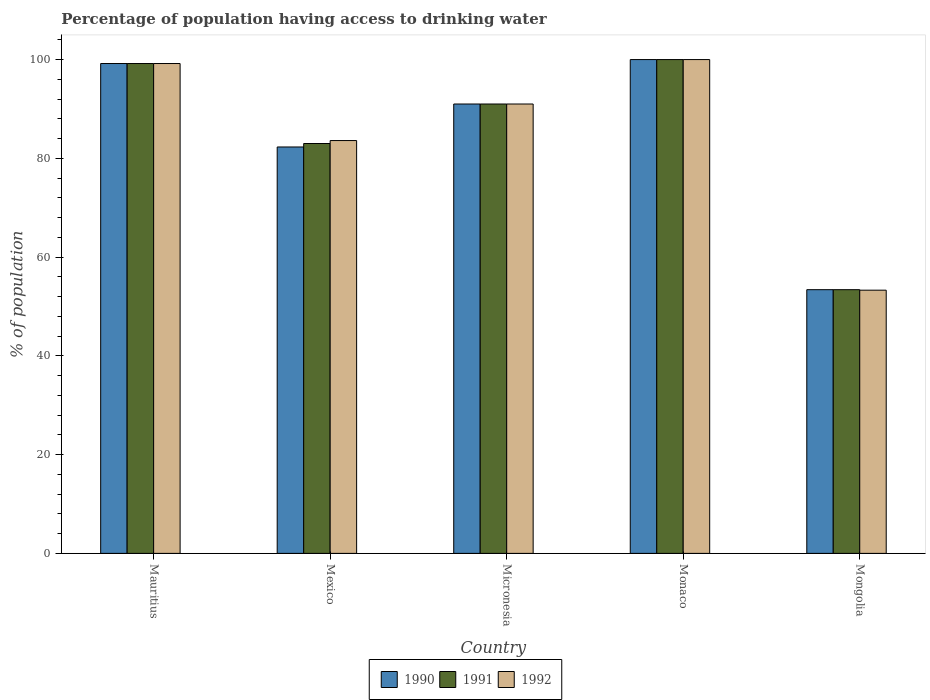How many different coloured bars are there?
Your answer should be very brief. 3. How many groups of bars are there?
Keep it short and to the point. 5. How many bars are there on the 1st tick from the right?
Ensure brevity in your answer.  3. What is the label of the 5th group of bars from the left?
Offer a very short reply. Mongolia. In how many cases, is the number of bars for a given country not equal to the number of legend labels?
Make the answer very short. 0. What is the percentage of population having access to drinking water in 1992 in Mexico?
Ensure brevity in your answer.  83.6. Across all countries, what is the minimum percentage of population having access to drinking water in 1990?
Ensure brevity in your answer.  53.4. In which country was the percentage of population having access to drinking water in 1992 maximum?
Provide a short and direct response. Monaco. In which country was the percentage of population having access to drinking water in 1991 minimum?
Ensure brevity in your answer.  Mongolia. What is the total percentage of population having access to drinking water in 1990 in the graph?
Offer a very short reply. 425.9. What is the difference between the percentage of population having access to drinking water in 1991 in Mauritius and the percentage of population having access to drinking water in 1992 in Monaco?
Your answer should be very brief. -0.8. What is the average percentage of population having access to drinking water in 1992 per country?
Your answer should be compact. 85.42. What is the ratio of the percentage of population having access to drinking water in 1992 in Mexico to that in Micronesia?
Ensure brevity in your answer.  0.92. Is the difference between the percentage of population having access to drinking water in 1990 in Mexico and Micronesia greater than the difference between the percentage of population having access to drinking water in 1991 in Mexico and Micronesia?
Your answer should be compact. No. What is the difference between the highest and the second highest percentage of population having access to drinking water in 1991?
Provide a short and direct response. -8.2. What is the difference between the highest and the lowest percentage of population having access to drinking water in 1991?
Offer a very short reply. 46.6. What does the 2nd bar from the left in Mauritius represents?
Your answer should be very brief. 1991. What does the 3rd bar from the right in Micronesia represents?
Your answer should be very brief. 1990. How many bars are there?
Offer a terse response. 15. Are all the bars in the graph horizontal?
Your answer should be compact. No. What is the difference between two consecutive major ticks on the Y-axis?
Your answer should be compact. 20. Are the values on the major ticks of Y-axis written in scientific E-notation?
Keep it short and to the point. No. What is the title of the graph?
Your answer should be very brief. Percentage of population having access to drinking water. What is the label or title of the Y-axis?
Keep it short and to the point. % of population. What is the % of population in 1990 in Mauritius?
Offer a terse response. 99.2. What is the % of population of 1991 in Mauritius?
Ensure brevity in your answer.  99.2. What is the % of population of 1992 in Mauritius?
Your response must be concise. 99.2. What is the % of population in 1990 in Mexico?
Ensure brevity in your answer.  82.3. What is the % of population in 1992 in Mexico?
Offer a very short reply. 83.6. What is the % of population in 1990 in Micronesia?
Your answer should be very brief. 91. What is the % of population of 1991 in Micronesia?
Keep it short and to the point. 91. What is the % of population of 1992 in Micronesia?
Your answer should be compact. 91. What is the % of population of 1992 in Monaco?
Provide a succinct answer. 100. What is the % of population in 1990 in Mongolia?
Your response must be concise. 53.4. What is the % of population of 1991 in Mongolia?
Your answer should be very brief. 53.4. What is the % of population of 1992 in Mongolia?
Offer a very short reply. 53.3. Across all countries, what is the minimum % of population of 1990?
Your answer should be compact. 53.4. Across all countries, what is the minimum % of population of 1991?
Your answer should be very brief. 53.4. Across all countries, what is the minimum % of population of 1992?
Your response must be concise. 53.3. What is the total % of population in 1990 in the graph?
Your answer should be very brief. 425.9. What is the total % of population in 1991 in the graph?
Your answer should be compact. 426.6. What is the total % of population of 1992 in the graph?
Keep it short and to the point. 427.1. What is the difference between the % of population of 1990 in Mauritius and that in Micronesia?
Your answer should be very brief. 8.2. What is the difference between the % of population of 1991 in Mauritius and that in Micronesia?
Give a very brief answer. 8.2. What is the difference between the % of population in 1990 in Mauritius and that in Monaco?
Give a very brief answer. -0.8. What is the difference between the % of population of 1992 in Mauritius and that in Monaco?
Your response must be concise. -0.8. What is the difference between the % of population in 1990 in Mauritius and that in Mongolia?
Your response must be concise. 45.8. What is the difference between the % of population of 1991 in Mauritius and that in Mongolia?
Give a very brief answer. 45.8. What is the difference between the % of population in 1992 in Mauritius and that in Mongolia?
Offer a very short reply. 45.9. What is the difference between the % of population in 1990 in Mexico and that in Micronesia?
Keep it short and to the point. -8.7. What is the difference between the % of population of 1991 in Mexico and that in Micronesia?
Provide a short and direct response. -8. What is the difference between the % of population of 1990 in Mexico and that in Monaco?
Keep it short and to the point. -17.7. What is the difference between the % of population of 1991 in Mexico and that in Monaco?
Your answer should be compact. -17. What is the difference between the % of population of 1992 in Mexico and that in Monaco?
Make the answer very short. -16.4. What is the difference between the % of population of 1990 in Mexico and that in Mongolia?
Offer a terse response. 28.9. What is the difference between the % of population of 1991 in Mexico and that in Mongolia?
Offer a very short reply. 29.6. What is the difference between the % of population in 1992 in Mexico and that in Mongolia?
Your answer should be very brief. 30.3. What is the difference between the % of population in 1990 in Micronesia and that in Monaco?
Make the answer very short. -9. What is the difference between the % of population of 1992 in Micronesia and that in Monaco?
Give a very brief answer. -9. What is the difference between the % of population in 1990 in Micronesia and that in Mongolia?
Keep it short and to the point. 37.6. What is the difference between the % of population of 1991 in Micronesia and that in Mongolia?
Offer a terse response. 37.6. What is the difference between the % of population in 1992 in Micronesia and that in Mongolia?
Ensure brevity in your answer.  37.7. What is the difference between the % of population in 1990 in Monaco and that in Mongolia?
Keep it short and to the point. 46.6. What is the difference between the % of population of 1991 in Monaco and that in Mongolia?
Make the answer very short. 46.6. What is the difference between the % of population in 1992 in Monaco and that in Mongolia?
Make the answer very short. 46.7. What is the difference between the % of population in 1991 in Mauritius and the % of population in 1992 in Mexico?
Ensure brevity in your answer.  15.6. What is the difference between the % of population in 1990 in Mauritius and the % of population in 1992 in Micronesia?
Your answer should be very brief. 8.2. What is the difference between the % of population of 1990 in Mauritius and the % of population of 1991 in Monaco?
Provide a short and direct response. -0.8. What is the difference between the % of population in 1990 in Mauritius and the % of population in 1991 in Mongolia?
Provide a succinct answer. 45.8. What is the difference between the % of population of 1990 in Mauritius and the % of population of 1992 in Mongolia?
Keep it short and to the point. 45.9. What is the difference between the % of population of 1991 in Mauritius and the % of population of 1992 in Mongolia?
Provide a short and direct response. 45.9. What is the difference between the % of population in 1991 in Mexico and the % of population in 1992 in Micronesia?
Keep it short and to the point. -8. What is the difference between the % of population of 1990 in Mexico and the % of population of 1991 in Monaco?
Offer a terse response. -17.7. What is the difference between the % of population of 1990 in Mexico and the % of population of 1992 in Monaco?
Ensure brevity in your answer.  -17.7. What is the difference between the % of population in 1991 in Mexico and the % of population in 1992 in Monaco?
Provide a succinct answer. -17. What is the difference between the % of population of 1990 in Mexico and the % of population of 1991 in Mongolia?
Your response must be concise. 28.9. What is the difference between the % of population of 1991 in Mexico and the % of population of 1992 in Mongolia?
Your answer should be compact. 29.7. What is the difference between the % of population in 1990 in Micronesia and the % of population in 1991 in Monaco?
Keep it short and to the point. -9. What is the difference between the % of population in 1990 in Micronesia and the % of population in 1992 in Monaco?
Ensure brevity in your answer.  -9. What is the difference between the % of population in 1990 in Micronesia and the % of population in 1991 in Mongolia?
Provide a succinct answer. 37.6. What is the difference between the % of population of 1990 in Micronesia and the % of population of 1992 in Mongolia?
Your answer should be very brief. 37.7. What is the difference between the % of population of 1991 in Micronesia and the % of population of 1992 in Mongolia?
Ensure brevity in your answer.  37.7. What is the difference between the % of population of 1990 in Monaco and the % of population of 1991 in Mongolia?
Keep it short and to the point. 46.6. What is the difference between the % of population in 1990 in Monaco and the % of population in 1992 in Mongolia?
Give a very brief answer. 46.7. What is the difference between the % of population of 1991 in Monaco and the % of population of 1992 in Mongolia?
Provide a succinct answer. 46.7. What is the average % of population in 1990 per country?
Provide a succinct answer. 85.18. What is the average % of population of 1991 per country?
Offer a terse response. 85.32. What is the average % of population of 1992 per country?
Make the answer very short. 85.42. What is the difference between the % of population of 1991 and % of population of 1992 in Mauritius?
Ensure brevity in your answer.  0. What is the difference between the % of population in 1990 and % of population in 1991 in Mexico?
Give a very brief answer. -0.7. What is the difference between the % of population of 1990 and % of population of 1992 in Mexico?
Ensure brevity in your answer.  -1.3. What is the difference between the % of population in 1990 and % of population in 1991 in Micronesia?
Your answer should be compact. 0. What is the difference between the % of population of 1990 and % of population of 1991 in Monaco?
Give a very brief answer. 0. What is the difference between the % of population in 1990 and % of population in 1991 in Mongolia?
Your answer should be compact. 0. What is the difference between the % of population of 1990 and % of population of 1992 in Mongolia?
Make the answer very short. 0.1. What is the ratio of the % of population of 1990 in Mauritius to that in Mexico?
Offer a terse response. 1.21. What is the ratio of the % of population in 1991 in Mauritius to that in Mexico?
Provide a short and direct response. 1.2. What is the ratio of the % of population of 1992 in Mauritius to that in Mexico?
Your response must be concise. 1.19. What is the ratio of the % of population in 1990 in Mauritius to that in Micronesia?
Keep it short and to the point. 1.09. What is the ratio of the % of population of 1991 in Mauritius to that in Micronesia?
Ensure brevity in your answer.  1.09. What is the ratio of the % of population of 1992 in Mauritius to that in Micronesia?
Your answer should be compact. 1.09. What is the ratio of the % of population in 1990 in Mauritius to that in Monaco?
Offer a very short reply. 0.99. What is the ratio of the % of population in 1991 in Mauritius to that in Monaco?
Your answer should be compact. 0.99. What is the ratio of the % of population of 1990 in Mauritius to that in Mongolia?
Ensure brevity in your answer.  1.86. What is the ratio of the % of population of 1991 in Mauritius to that in Mongolia?
Give a very brief answer. 1.86. What is the ratio of the % of population of 1992 in Mauritius to that in Mongolia?
Ensure brevity in your answer.  1.86. What is the ratio of the % of population in 1990 in Mexico to that in Micronesia?
Offer a terse response. 0.9. What is the ratio of the % of population of 1991 in Mexico to that in Micronesia?
Offer a terse response. 0.91. What is the ratio of the % of population in 1992 in Mexico to that in Micronesia?
Give a very brief answer. 0.92. What is the ratio of the % of population in 1990 in Mexico to that in Monaco?
Offer a terse response. 0.82. What is the ratio of the % of population in 1991 in Mexico to that in Monaco?
Your answer should be compact. 0.83. What is the ratio of the % of population of 1992 in Mexico to that in Monaco?
Provide a short and direct response. 0.84. What is the ratio of the % of population of 1990 in Mexico to that in Mongolia?
Keep it short and to the point. 1.54. What is the ratio of the % of population in 1991 in Mexico to that in Mongolia?
Provide a succinct answer. 1.55. What is the ratio of the % of population of 1992 in Mexico to that in Mongolia?
Offer a terse response. 1.57. What is the ratio of the % of population in 1990 in Micronesia to that in Monaco?
Provide a succinct answer. 0.91. What is the ratio of the % of population in 1991 in Micronesia to that in Monaco?
Your answer should be compact. 0.91. What is the ratio of the % of population in 1992 in Micronesia to that in Monaco?
Keep it short and to the point. 0.91. What is the ratio of the % of population in 1990 in Micronesia to that in Mongolia?
Ensure brevity in your answer.  1.7. What is the ratio of the % of population of 1991 in Micronesia to that in Mongolia?
Offer a terse response. 1.7. What is the ratio of the % of population of 1992 in Micronesia to that in Mongolia?
Ensure brevity in your answer.  1.71. What is the ratio of the % of population of 1990 in Monaco to that in Mongolia?
Offer a terse response. 1.87. What is the ratio of the % of population in 1991 in Monaco to that in Mongolia?
Provide a succinct answer. 1.87. What is the ratio of the % of population in 1992 in Monaco to that in Mongolia?
Offer a terse response. 1.88. What is the difference between the highest and the second highest % of population of 1990?
Give a very brief answer. 0.8. What is the difference between the highest and the lowest % of population of 1990?
Your response must be concise. 46.6. What is the difference between the highest and the lowest % of population of 1991?
Ensure brevity in your answer.  46.6. What is the difference between the highest and the lowest % of population in 1992?
Provide a succinct answer. 46.7. 